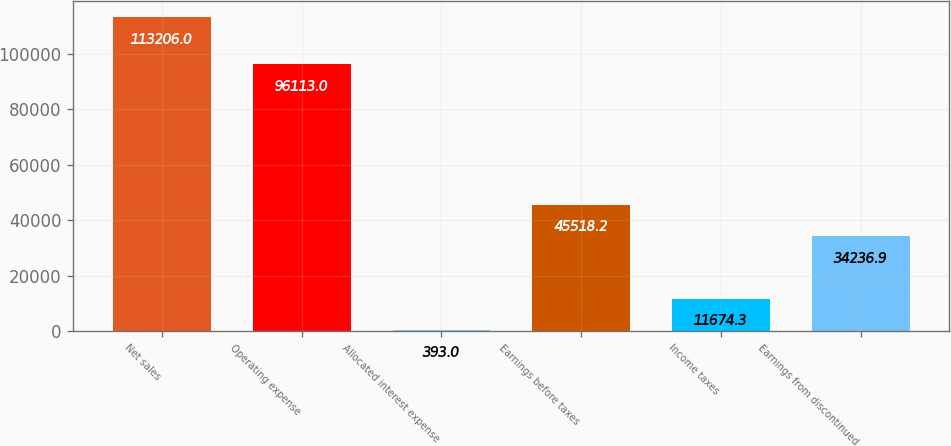Convert chart. <chart><loc_0><loc_0><loc_500><loc_500><bar_chart><fcel>Net sales<fcel>Operating expense<fcel>Allocated interest expense<fcel>Earnings before taxes<fcel>Income taxes<fcel>Earnings from discontinued<nl><fcel>113206<fcel>96113<fcel>393<fcel>45518.2<fcel>11674.3<fcel>34236.9<nl></chart> 